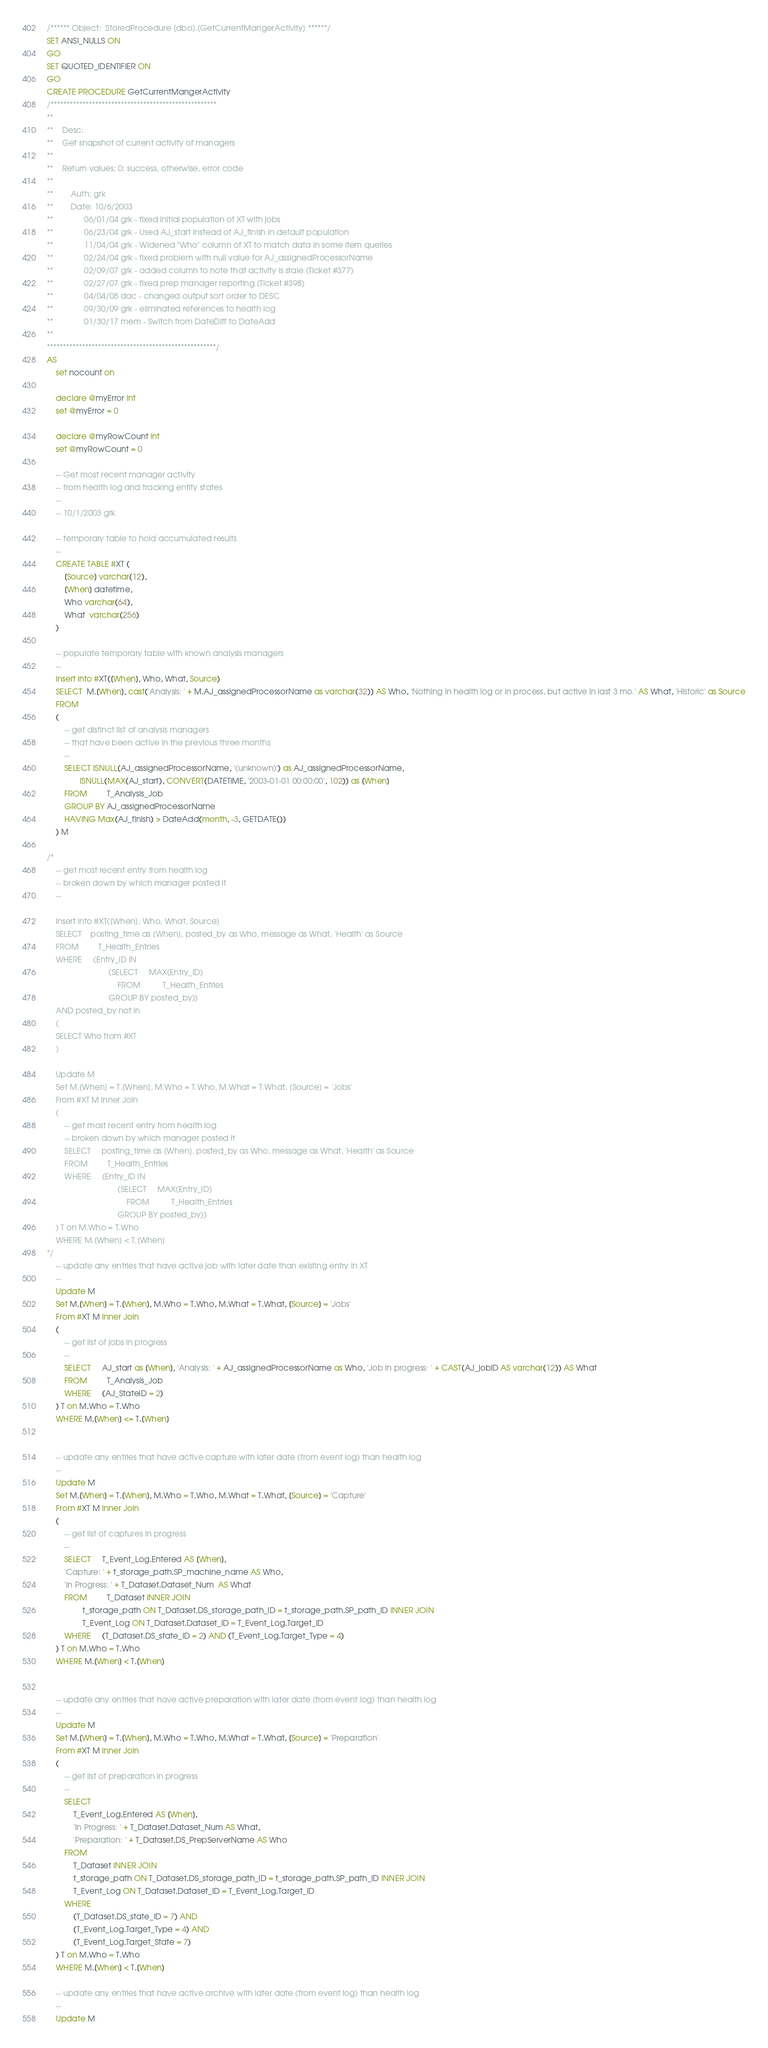Convert code to text. <code><loc_0><loc_0><loc_500><loc_500><_SQL_>/****** Object:  StoredProcedure [dbo].[GetCurrentMangerActivity] ******/
SET ANSI_NULLS ON
GO
SET QUOTED_IDENTIFIER ON
GO
CREATE PROCEDURE GetCurrentMangerActivity
/****************************************************
**
**	Desc: 
**	Get snapshot of current activity of managers
**
**	Return values: 0: success, otherwise, error code
**
**		Auth: grk
**		Date: 10/6/2003
**			  06/01/04 grk - fixed initial population of XT with jobs
**			  06/23/04 grk - Used AJ_start instead of AJ_finish in default population
**			  11/04/04 grk - Widened "Who" column of XT to match data in some item queries
**			  02/24/04 grk - fixed problem with null value for AJ_assignedProcessorName
**			  02/09/07 grk - added column to note that activity is stale (Ticket #377)
**			  02/27/07 grk - fixed prep manager reporting (Ticket #398)
**			  04/04/08 dac - changed output sort order to DESC
**			  09/30/09 grk - eliminated references to health log
**			  01/30/17 mem - Switch from DateDiff to DateAdd
**    
*****************************************************/
AS
	set nocount on

	declare @myError int
	set @myError = 0

	declare @myRowCount int
	set @myRowCount = 0

	-- Get most recent manager activity 
	-- from health log and tracking entity states
	--
	-- 10/1/2003 grk

	-- temporary table to hold accumulated results
	--
	CREATE TABLE #XT (
		[Source] varchar(12),
		[When] datetime, 
		Who varchar(64), 
		What  varchar(256)
	)

	-- populate temporary table with known analysis managers
	--
	insert into #XT([When], Who, What, Source)
	SELECT  M.[When], cast('Analysis: ' + M.AJ_assignedProcessorName as varchar(32)) AS Who, 'Nothing in health log or in process, but active in last 3 mo.' AS What, 'Historic' as Source
	FROM
	(
		-- get distinct list of analysis managers 
		-- that have been active in the previous three months
		--
		SELECT ISNULL(AJ_assignedProcessorName, '(unknown)') as AJ_assignedProcessorName, 
		       ISNULL(MAX(AJ_start), CONVERT(DATETIME, '2003-01-01 00:00:00', 102)) as [When]
		FROM         T_Analysis_Job
		GROUP BY AJ_assignedProcessorName
		HAVING Max(AJ_finish) > DateAdd(month, -3, GETDATE())
	) M

/*
	-- get most recent entry from health log 
	-- broken down by which manager posted it
	--

	insert into #XT([When], Who, What, Source) 
	SELECT    posting_time as [When], posted_by as Who, message as What, 'Health' as Source
	FROM         T_Health_Entries
	WHERE     (Entry_ID IN
							(SELECT     MAX(Entry_ID)
								FROM          T_Health_Entries
							GROUP BY posted_by))
	AND posted_by not in 
	(
	SELECT Who from #XT
	)

	Update M
	Set M.[When] = T.[When], M.Who = T.Who, M.What = T.What, [Source] = 'Jobs'
	From #XT M inner Join 
	(
		-- get most recent entry from health log 
		-- broken down by which manager posted it
		SELECT     posting_time as [When], posted_by as Who, message as What, 'Health' as Source
		FROM         T_Health_Entries
		WHERE     (Entry_ID IN
								(SELECT     MAX(Entry_ID)
									FROM          T_Health_Entries
								GROUP BY posted_by))
	) T on M.Who = T.Who
	WHERE M.[When] < T.[When]
*/
	-- update any entries that have active job with later date than existing entry in XT
	--
	Update M
	Set M.[When] = T.[When], M.Who = T.Who, M.What = T.What, [Source] = 'Jobs'
	From #XT M inner Join 
	(
		-- get list of jobs in progress
		--
		SELECT     AJ_start as [When], 'Analysis: ' + AJ_assignedProcessorName as Who, 'Job in progress: ' + CAST(AJ_jobID AS varchar(12)) AS What
		FROM         T_Analysis_Job
		WHERE     (AJ_StateID = 2)
	) T on M.Who = T.Who
	WHERE M.[When] <= T.[When]


	-- update any entries that have active capture with later date (from event log) than health log
	--
	Update M
	Set M.[When] = T.[When], M.Who = T.Who, M.What = T.What, [Source] = 'Capture'
	From #XT M inner Join 
	(
		-- get list of captures in progress
		--
		SELECT     T_Event_Log.Entered AS [When], 
		'Capture: ' + t_storage_path.SP_machine_name AS Who, 
		'In Progress: ' + T_Dataset.Dataset_Num  AS What
		FROM         T_Dataset INNER JOIN
				t_storage_path ON T_Dataset.DS_storage_path_ID = t_storage_path.SP_path_ID INNER JOIN
				T_Event_Log ON T_Dataset.Dataset_ID = T_Event_Log.Target_ID
		WHERE     (T_Dataset.DS_state_ID = 2) AND (T_Event_Log.Target_Type = 4)
	) T on M.Who = T.Who
	WHERE M.[When] < T.[When]


	-- update any entries that have active preparation with later date (from event log) than health log
	--
	Update M
	Set M.[When] = T.[When], M.Who = T.Who, M.What = T.What, [Source] = 'Preparation'
	From #XT M inner Join 
	(
		-- get list of preparation in progress
		--
		SELECT
			T_Event_Log.Entered AS [When], 
			'In Progress: ' + T_Dataset.Dataset_Num AS What, 
			'Preparation: ' + T_Dataset.DS_PrepServerName AS Who
		FROM
			T_Dataset INNER JOIN
			t_storage_path ON T_Dataset.DS_storage_path_ID = t_storage_path.SP_path_ID INNER JOIN
			T_Event_Log ON T_Dataset.Dataset_ID = T_Event_Log.Target_ID
		WHERE     
			(T_Dataset.DS_state_ID = 7) AND 
			(T_Event_Log.Target_Type = 4) AND 
			(T_Event_Log.Target_State = 7)
	) T on M.Who = T.Who
	WHERE M.[When] < T.[When]

	-- update any entries that have active archive with later date (from event log) than health log
	--
	Update M</code> 